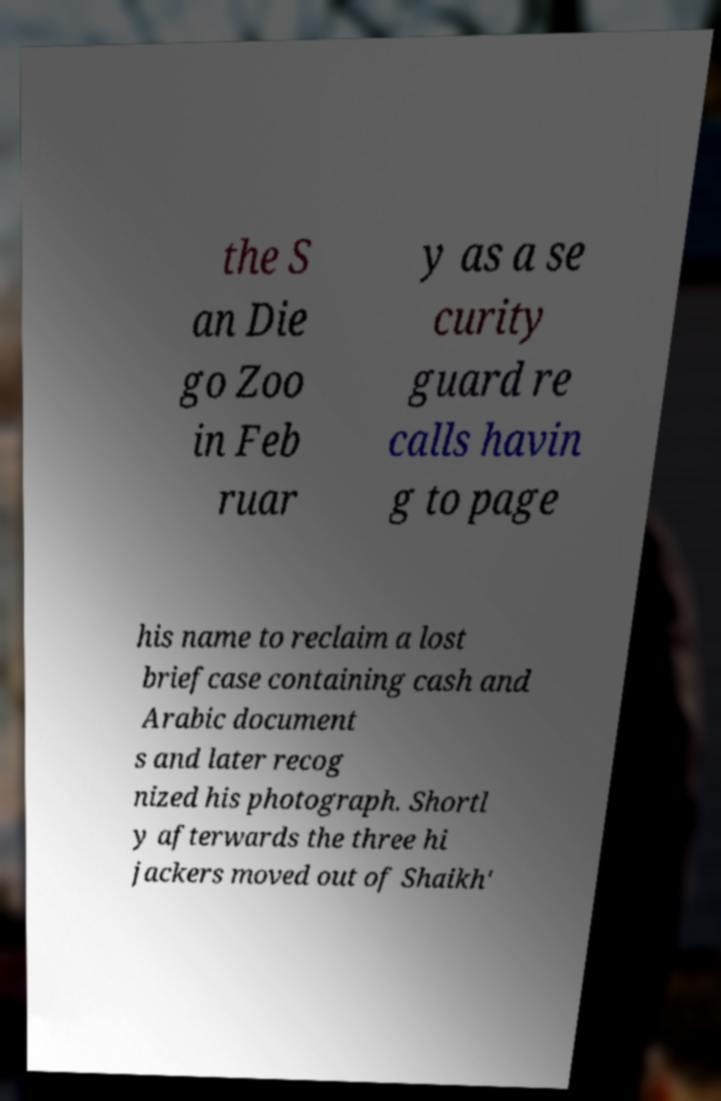Could you extract and type out the text from this image? the S an Die go Zoo in Feb ruar y as a se curity guard re calls havin g to page his name to reclaim a lost briefcase containing cash and Arabic document s and later recog nized his photograph. Shortl y afterwards the three hi jackers moved out of Shaikh' 